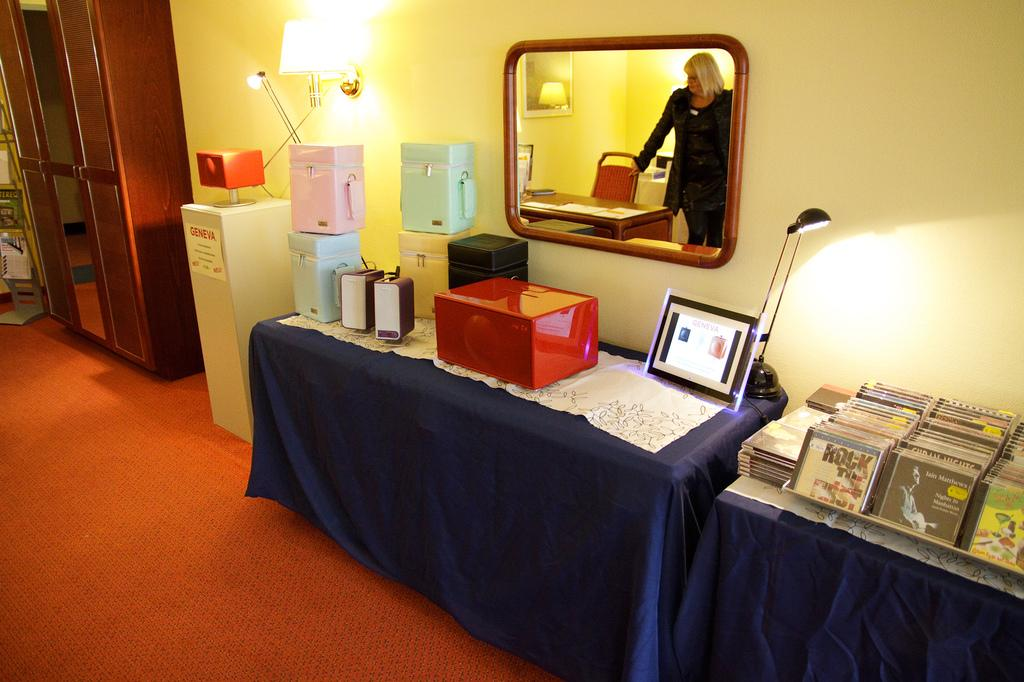<image>
Write a terse but informative summary of the picture. A woman stands in a room with a cabinet that says GENEVA and seveeral CDs including one that says ROCK THEE FIRST 